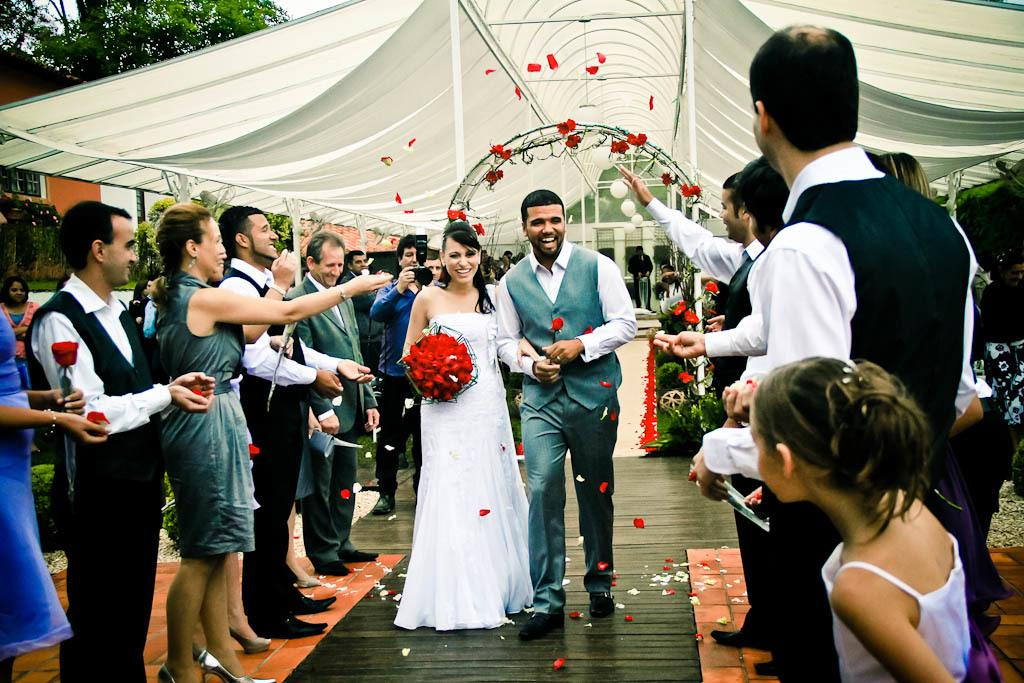What are the main subjects in the image? There is a couple walking in the image, and there are people standing in the image. What is the color shade at the top of the image? There is a white color shade at the top of the image. What type of vegetation can be seen in the image? There are green color trees at the left side top of the image. What type of record is being played by the couple in the image? There is no record or music player visible in the image; the main subjects are the couple walking and the people standing. 